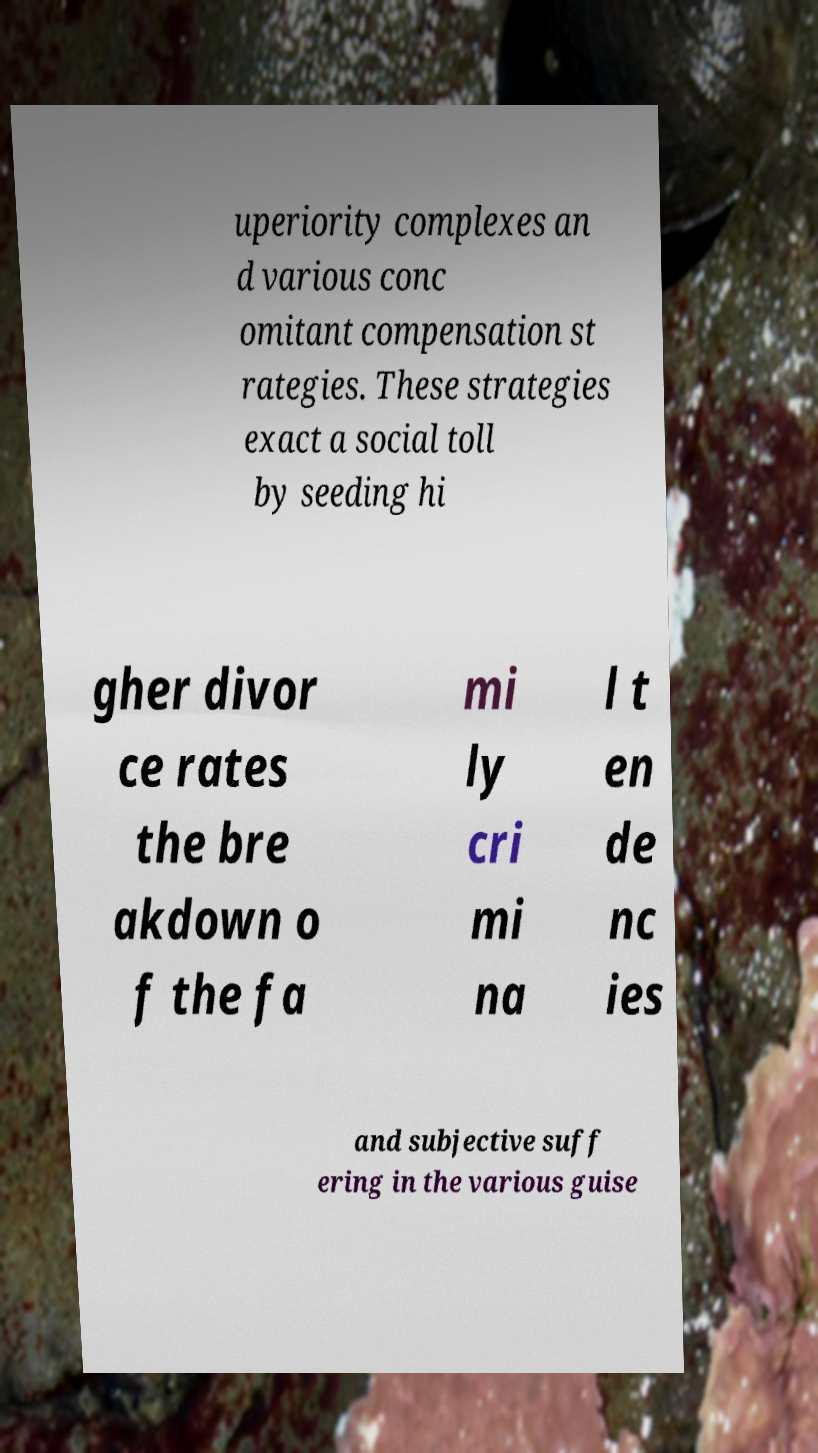I need the written content from this picture converted into text. Can you do that? uperiority complexes an d various conc omitant compensation st rategies. These strategies exact a social toll by seeding hi gher divor ce rates the bre akdown o f the fa mi ly cri mi na l t en de nc ies and subjective suff ering in the various guise 